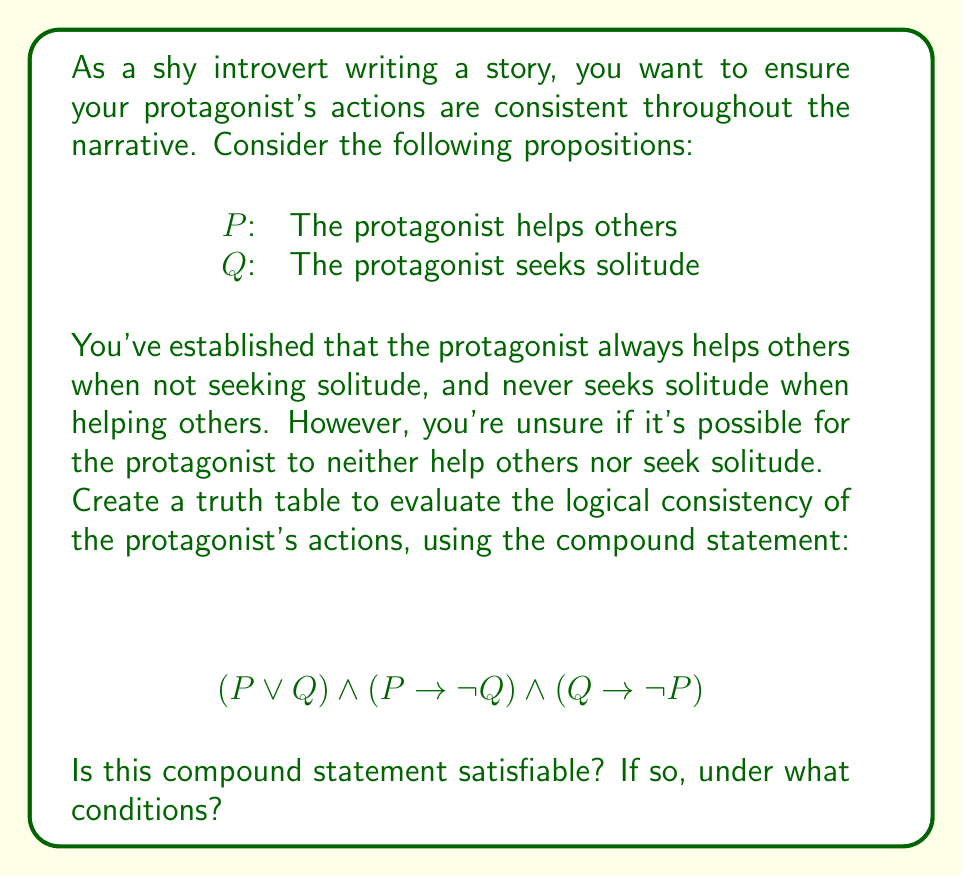Show me your answer to this math problem. Let's approach this step-by-step:

1) First, we need to create a truth table for the given compound statement. The table will have columns for P, Q, and each part of the compound statement.

2) The truth table:

   | P | Q | P ∨ Q | P → ¬Q | Q → ¬P | (P ∨ Q) ∧ (P → ¬Q) ∧ (Q → ¬P) |
   |---|---|-------|--------|--------|----------------------------------|
   | T | T |   T   |   F    |   F    |               F                  |
   | T | F |   T   |   T    |   T    |               T                  |
   | F | T |   T   |   T    |   T    |               T                  |
   | F | F |   F   |   T    |   T    |               F                  |

3) Let's break down each column:
   - P ∨ Q: True when either P or Q (or both) are true
   - P → ¬Q: False only when P is true and Q is true
   - Q → ¬P: False only when Q is true and P is true
   - The final column is the AND of all previous columns

4) The compound statement is satisfiable if there's at least one row where the final column is True.

5) We can see that the statement is True in two cases:
   - When P is True and Q is False (row 2)
   - When P is False and Q is True (row 3)

6) Interpreting these results in the context of the story:
   - The protagonist can help others while not seeking solitude (P true, Q false)
   - The protagonist can seek solitude while not helping others (P false, Q true)
   - The protagonist cannot both help others and seek solitude simultaneously
   - The protagonist cannot neither help others nor seek solitude (both false)
Answer: The compound statement is satisfiable when either P is true and Q is false, or P is false and Q is true. 